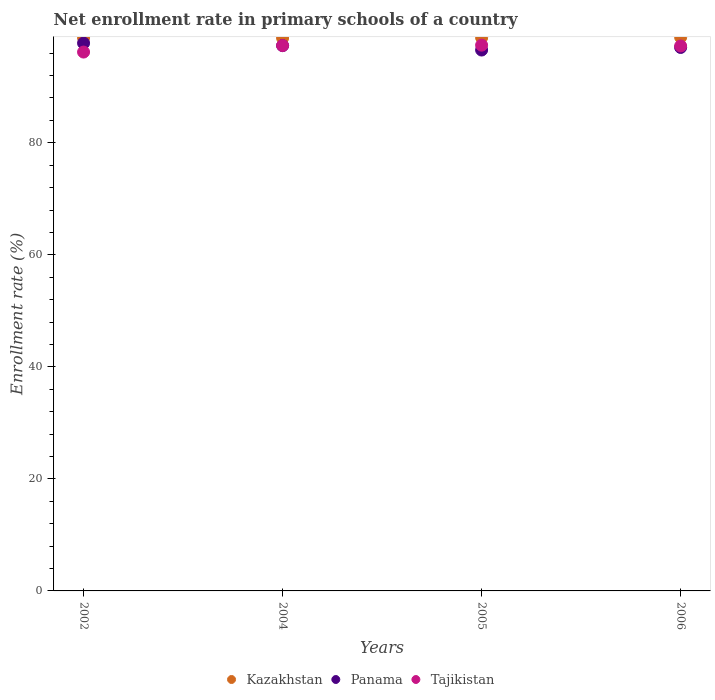How many different coloured dotlines are there?
Ensure brevity in your answer.  3. Is the number of dotlines equal to the number of legend labels?
Give a very brief answer. Yes. What is the enrollment rate in primary schools in Panama in 2004?
Offer a terse response. 97.35. Across all years, what is the maximum enrollment rate in primary schools in Tajikistan?
Your answer should be very brief. 97.43. Across all years, what is the minimum enrollment rate in primary schools in Kazakhstan?
Give a very brief answer. 98.71. In which year was the enrollment rate in primary schools in Kazakhstan maximum?
Ensure brevity in your answer.  2006. What is the total enrollment rate in primary schools in Panama in the graph?
Your answer should be compact. 388.72. What is the difference between the enrollment rate in primary schools in Panama in 2002 and that in 2004?
Give a very brief answer. 0.44. What is the difference between the enrollment rate in primary schools in Kazakhstan in 2006 and the enrollment rate in primary schools in Tajikistan in 2002?
Your response must be concise. 2.63. What is the average enrollment rate in primary schools in Tajikistan per year?
Give a very brief answer. 97.07. In the year 2005, what is the difference between the enrollment rate in primary schools in Tajikistan and enrollment rate in primary schools in Kazakhstan?
Ensure brevity in your answer.  -1.33. In how many years, is the enrollment rate in primary schools in Kazakhstan greater than 4 %?
Ensure brevity in your answer.  4. What is the ratio of the enrollment rate in primary schools in Kazakhstan in 2002 to that in 2006?
Offer a terse response. 1. Is the enrollment rate in primary schools in Kazakhstan in 2004 less than that in 2005?
Keep it short and to the point. Yes. What is the difference between the highest and the second highest enrollment rate in primary schools in Tajikistan?
Make the answer very short. 0.07. What is the difference between the highest and the lowest enrollment rate in primary schools in Tajikistan?
Ensure brevity in your answer.  1.23. Is the sum of the enrollment rate in primary schools in Panama in 2004 and 2005 greater than the maximum enrollment rate in primary schools in Tajikistan across all years?
Make the answer very short. Yes. Is it the case that in every year, the sum of the enrollment rate in primary schools in Panama and enrollment rate in primary schools in Kazakhstan  is greater than the enrollment rate in primary schools in Tajikistan?
Provide a succinct answer. Yes. Does the enrollment rate in primary schools in Kazakhstan monotonically increase over the years?
Your answer should be very brief. No. Is the enrollment rate in primary schools in Tajikistan strictly greater than the enrollment rate in primary schools in Kazakhstan over the years?
Offer a terse response. No. Is the enrollment rate in primary schools in Tajikistan strictly less than the enrollment rate in primary schools in Panama over the years?
Provide a succinct answer. No. How many dotlines are there?
Ensure brevity in your answer.  3. What is the difference between two consecutive major ticks on the Y-axis?
Your answer should be very brief. 20. Does the graph contain any zero values?
Make the answer very short. No. How are the legend labels stacked?
Offer a very short reply. Horizontal. What is the title of the graph?
Your answer should be very brief. Net enrollment rate in primary schools of a country. Does "Kenya" appear as one of the legend labels in the graph?
Provide a short and direct response. No. What is the label or title of the X-axis?
Provide a succinct answer. Years. What is the label or title of the Y-axis?
Offer a terse response. Enrollment rate (%). What is the Enrollment rate (%) in Kazakhstan in 2002?
Provide a short and direct response. 98.74. What is the Enrollment rate (%) of Panama in 2002?
Your answer should be very brief. 97.79. What is the Enrollment rate (%) in Tajikistan in 2002?
Your answer should be very brief. 96.2. What is the Enrollment rate (%) of Kazakhstan in 2004?
Offer a terse response. 98.71. What is the Enrollment rate (%) of Panama in 2004?
Your answer should be very brief. 97.35. What is the Enrollment rate (%) in Tajikistan in 2004?
Offer a very short reply. 97.36. What is the Enrollment rate (%) in Kazakhstan in 2005?
Ensure brevity in your answer.  98.76. What is the Enrollment rate (%) of Panama in 2005?
Make the answer very short. 96.56. What is the Enrollment rate (%) in Tajikistan in 2005?
Offer a terse response. 97.43. What is the Enrollment rate (%) in Kazakhstan in 2006?
Your answer should be very brief. 98.83. What is the Enrollment rate (%) of Panama in 2006?
Offer a terse response. 97.02. What is the Enrollment rate (%) in Tajikistan in 2006?
Keep it short and to the point. 97.28. Across all years, what is the maximum Enrollment rate (%) of Kazakhstan?
Offer a very short reply. 98.83. Across all years, what is the maximum Enrollment rate (%) in Panama?
Your answer should be very brief. 97.79. Across all years, what is the maximum Enrollment rate (%) of Tajikistan?
Offer a very short reply. 97.43. Across all years, what is the minimum Enrollment rate (%) of Kazakhstan?
Make the answer very short. 98.71. Across all years, what is the minimum Enrollment rate (%) in Panama?
Give a very brief answer. 96.56. Across all years, what is the minimum Enrollment rate (%) of Tajikistan?
Provide a short and direct response. 96.2. What is the total Enrollment rate (%) in Kazakhstan in the graph?
Give a very brief answer. 395.04. What is the total Enrollment rate (%) in Panama in the graph?
Your response must be concise. 388.72. What is the total Enrollment rate (%) in Tajikistan in the graph?
Keep it short and to the point. 388.27. What is the difference between the Enrollment rate (%) of Kazakhstan in 2002 and that in 2004?
Provide a short and direct response. 0.03. What is the difference between the Enrollment rate (%) of Panama in 2002 and that in 2004?
Provide a succinct answer. 0.44. What is the difference between the Enrollment rate (%) of Tajikistan in 2002 and that in 2004?
Offer a very short reply. -1.16. What is the difference between the Enrollment rate (%) of Kazakhstan in 2002 and that in 2005?
Your answer should be very brief. -0.02. What is the difference between the Enrollment rate (%) in Panama in 2002 and that in 2005?
Offer a very short reply. 1.23. What is the difference between the Enrollment rate (%) in Tajikistan in 2002 and that in 2005?
Provide a short and direct response. -1.23. What is the difference between the Enrollment rate (%) of Kazakhstan in 2002 and that in 2006?
Make the answer very short. -0.09. What is the difference between the Enrollment rate (%) of Panama in 2002 and that in 2006?
Ensure brevity in your answer.  0.77. What is the difference between the Enrollment rate (%) of Tajikistan in 2002 and that in 2006?
Make the answer very short. -1.09. What is the difference between the Enrollment rate (%) in Kazakhstan in 2004 and that in 2005?
Your response must be concise. -0.06. What is the difference between the Enrollment rate (%) in Panama in 2004 and that in 2005?
Provide a short and direct response. 0.79. What is the difference between the Enrollment rate (%) of Tajikistan in 2004 and that in 2005?
Make the answer very short. -0.07. What is the difference between the Enrollment rate (%) of Kazakhstan in 2004 and that in 2006?
Ensure brevity in your answer.  -0.13. What is the difference between the Enrollment rate (%) of Panama in 2004 and that in 2006?
Offer a very short reply. 0.33. What is the difference between the Enrollment rate (%) of Tajikistan in 2004 and that in 2006?
Your response must be concise. 0.08. What is the difference between the Enrollment rate (%) in Kazakhstan in 2005 and that in 2006?
Keep it short and to the point. -0.07. What is the difference between the Enrollment rate (%) in Panama in 2005 and that in 2006?
Provide a succinct answer. -0.46. What is the difference between the Enrollment rate (%) of Tajikistan in 2005 and that in 2006?
Ensure brevity in your answer.  0.15. What is the difference between the Enrollment rate (%) in Kazakhstan in 2002 and the Enrollment rate (%) in Panama in 2004?
Offer a terse response. 1.39. What is the difference between the Enrollment rate (%) in Kazakhstan in 2002 and the Enrollment rate (%) in Tajikistan in 2004?
Offer a very short reply. 1.38. What is the difference between the Enrollment rate (%) in Panama in 2002 and the Enrollment rate (%) in Tajikistan in 2004?
Your response must be concise. 0.43. What is the difference between the Enrollment rate (%) in Kazakhstan in 2002 and the Enrollment rate (%) in Panama in 2005?
Give a very brief answer. 2.18. What is the difference between the Enrollment rate (%) in Kazakhstan in 2002 and the Enrollment rate (%) in Tajikistan in 2005?
Provide a short and direct response. 1.31. What is the difference between the Enrollment rate (%) of Panama in 2002 and the Enrollment rate (%) of Tajikistan in 2005?
Offer a very short reply. 0.36. What is the difference between the Enrollment rate (%) of Kazakhstan in 2002 and the Enrollment rate (%) of Panama in 2006?
Your response must be concise. 1.72. What is the difference between the Enrollment rate (%) of Kazakhstan in 2002 and the Enrollment rate (%) of Tajikistan in 2006?
Your answer should be very brief. 1.46. What is the difference between the Enrollment rate (%) of Panama in 2002 and the Enrollment rate (%) of Tajikistan in 2006?
Offer a very short reply. 0.51. What is the difference between the Enrollment rate (%) in Kazakhstan in 2004 and the Enrollment rate (%) in Panama in 2005?
Keep it short and to the point. 2.15. What is the difference between the Enrollment rate (%) of Kazakhstan in 2004 and the Enrollment rate (%) of Tajikistan in 2005?
Provide a short and direct response. 1.28. What is the difference between the Enrollment rate (%) in Panama in 2004 and the Enrollment rate (%) in Tajikistan in 2005?
Your answer should be compact. -0.08. What is the difference between the Enrollment rate (%) in Kazakhstan in 2004 and the Enrollment rate (%) in Panama in 2006?
Offer a terse response. 1.69. What is the difference between the Enrollment rate (%) of Kazakhstan in 2004 and the Enrollment rate (%) of Tajikistan in 2006?
Your answer should be very brief. 1.42. What is the difference between the Enrollment rate (%) of Panama in 2004 and the Enrollment rate (%) of Tajikistan in 2006?
Your answer should be very brief. 0.06. What is the difference between the Enrollment rate (%) in Kazakhstan in 2005 and the Enrollment rate (%) in Panama in 2006?
Offer a terse response. 1.74. What is the difference between the Enrollment rate (%) in Kazakhstan in 2005 and the Enrollment rate (%) in Tajikistan in 2006?
Offer a very short reply. 1.48. What is the difference between the Enrollment rate (%) in Panama in 2005 and the Enrollment rate (%) in Tajikistan in 2006?
Your answer should be very brief. -0.72. What is the average Enrollment rate (%) of Kazakhstan per year?
Provide a succinct answer. 98.76. What is the average Enrollment rate (%) in Panama per year?
Ensure brevity in your answer.  97.18. What is the average Enrollment rate (%) of Tajikistan per year?
Ensure brevity in your answer.  97.07. In the year 2002, what is the difference between the Enrollment rate (%) in Kazakhstan and Enrollment rate (%) in Panama?
Your answer should be very brief. 0.95. In the year 2002, what is the difference between the Enrollment rate (%) in Kazakhstan and Enrollment rate (%) in Tajikistan?
Keep it short and to the point. 2.54. In the year 2002, what is the difference between the Enrollment rate (%) in Panama and Enrollment rate (%) in Tajikistan?
Offer a terse response. 1.59. In the year 2004, what is the difference between the Enrollment rate (%) in Kazakhstan and Enrollment rate (%) in Panama?
Provide a short and direct response. 1.36. In the year 2004, what is the difference between the Enrollment rate (%) in Kazakhstan and Enrollment rate (%) in Tajikistan?
Ensure brevity in your answer.  1.35. In the year 2004, what is the difference between the Enrollment rate (%) in Panama and Enrollment rate (%) in Tajikistan?
Provide a succinct answer. -0.01. In the year 2005, what is the difference between the Enrollment rate (%) of Kazakhstan and Enrollment rate (%) of Panama?
Ensure brevity in your answer.  2.2. In the year 2005, what is the difference between the Enrollment rate (%) of Kazakhstan and Enrollment rate (%) of Tajikistan?
Provide a succinct answer. 1.33. In the year 2005, what is the difference between the Enrollment rate (%) in Panama and Enrollment rate (%) in Tajikistan?
Provide a short and direct response. -0.87. In the year 2006, what is the difference between the Enrollment rate (%) of Kazakhstan and Enrollment rate (%) of Panama?
Provide a succinct answer. 1.81. In the year 2006, what is the difference between the Enrollment rate (%) in Kazakhstan and Enrollment rate (%) in Tajikistan?
Your answer should be compact. 1.55. In the year 2006, what is the difference between the Enrollment rate (%) in Panama and Enrollment rate (%) in Tajikistan?
Your answer should be very brief. -0.26. What is the ratio of the Enrollment rate (%) in Kazakhstan in 2002 to that in 2005?
Give a very brief answer. 1. What is the ratio of the Enrollment rate (%) in Panama in 2002 to that in 2005?
Provide a short and direct response. 1.01. What is the ratio of the Enrollment rate (%) of Tajikistan in 2002 to that in 2005?
Your answer should be compact. 0.99. What is the ratio of the Enrollment rate (%) in Panama in 2002 to that in 2006?
Provide a succinct answer. 1.01. What is the ratio of the Enrollment rate (%) of Tajikistan in 2002 to that in 2006?
Offer a terse response. 0.99. What is the ratio of the Enrollment rate (%) of Kazakhstan in 2004 to that in 2005?
Your response must be concise. 1. What is the ratio of the Enrollment rate (%) of Panama in 2004 to that in 2005?
Your answer should be compact. 1.01. What is the ratio of the Enrollment rate (%) in Tajikistan in 2004 to that in 2005?
Give a very brief answer. 1. What is the ratio of the Enrollment rate (%) in Tajikistan in 2004 to that in 2006?
Your response must be concise. 1. What is the ratio of the Enrollment rate (%) of Tajikistan in 2005 to that in 2006?
Ensure brevity in your answer.  1. What is the difference between the highest and the second highest Enrollment rate (%) of Kazakhstan?
Ensure brevity in your answer.  0.07. What is the difference between the highest and the second highest Enrollment rate (%) of Panama?
Your response must be concise. 0.44. What is the difference between the highest and the second highest Enrollment rate (%) of Tajikistan?
Provide a succinct answer. 0.07. What is the difference between the highest and the lowest Enrollment rate (%) in Kazakhstan?
Your response must be concise. 0.13. What is the difference between the highest and the lowest Enrollment rate (%) in Panama?
Your response must be concise. 1.23. What is the difference between the highest and the lowest Enrollment rate (%) of Tajikistan?
Ensure brevity in your answer.  1.23. 